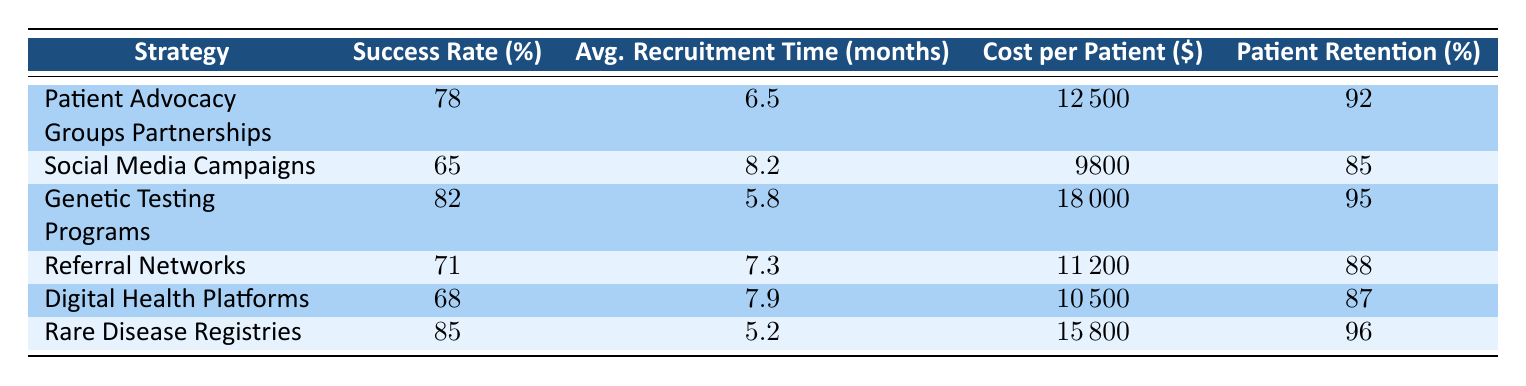What is the success rate of Genetic Testing Programs? The success rate of Genetic Testing Programs is listed directly in the table under the "Success Rate (%)" column. It shows a value of 82.
Answer: 82 What is the average recruitment time for Rare Disease Registries? The average recruitment time for Rare Disease Registries can be found in the table in the "Avg. Recruitment Time (months)" column, which has a value of 5.2 months.
Answer: 5.2 months Which recruitment strategy has the highest patient retention percentage? To find the recruitment strategy with the highest patient retention percentage, we examine the "Patient Retention (%)" column for all strategies. The highest value is 96, associated with Rare Disease Registries.
Answer: Rare Disease Registries Is the success rate for Social Media Campaigns greater than that for Referral Networks? The success rate for Social Media Campaigns is 65%, and the success rate for Referral Networks is 71%. Since 65 is less than 71, the answer is no.
Answer: No Calculate the average cost per patient across all strategies. To calculate the average cost per patient, sum the "Cost per Patient ($)" values: 12500 + 9800 + 18000 + 11200 + 10500 + 15800 = 88800. There are 6 strategies, so the average is 88800 / 6 = 14800.
Answer: 14800 What is the success rate difference between Rare Disease Registries and Genetic Testing Programs? The success rate for Rare Disease Registries is 85%, while for Genetic Testing Programs it is 82%. The difference is 85 - 82 = 3.
Answer: 3 Do Digital Health Platforms have a higher success rate than Patient Advocacy Groups Partnerships? The success rate for Digital Health Platforms is 68%, compared to 78% for Patient Advocacy Groups Partnerships. Since 68 is not greater than 78, the answer is no.
Answer: No Which recruitment strategy requires the most time on average for patient recruitment? By reviewing the "Avg. Recruitment Time (months)" column, Digital Health Platforms has the highest value at 7.9 months.
Answer: Digital Health Platforms What is the total patient retention percentage for all the listed strategies combined? To get the total patient retention percentage, we have to look at the individual retention percentages: (92 + 85 + 95 + 88 + 87 + 96) / 6 = 90.5. Therefore, the average patient retention across all strategies is 90.5%.
Answer: 90.5% 